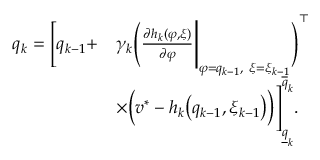<formula> <loc_0><loc_0><loc_500><loc_500>\begin{array} { r l } { q _ { k } = \Big [ q _ { k - 1 } + } & { \gamma _ { k } \Big ( \frac { \partial h _ { k } ( \varphi , \xi ) } { \partial \varphi } \Big | _ { \varphi = q _ { k - 1 } , \xi = \xi _ { k - 1 } } \Big ) ^ { \top } } \\ & { \times \Big ( v ^ { * } - h _ { k } \Big ( q _ { k - 1 } , \xi _ { k - 1 } \Big ) \Big ) \Big ] _ { \underline { q } _ { k } } ^ { \overline { q } _ { k } } . } \end{array}</formula> 